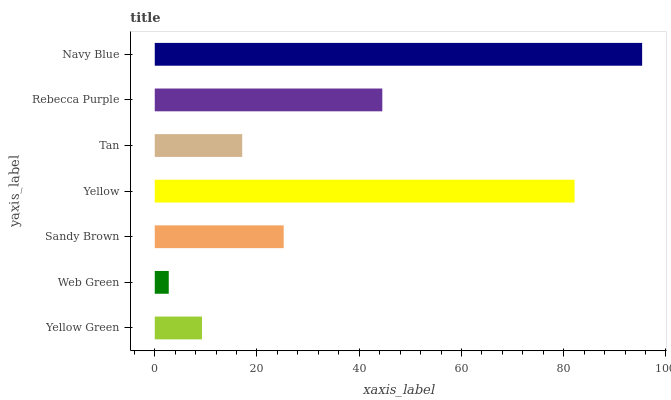Is Web Green the minimum?
Answer yes or no. Yes. Is Navy Blue the maximum?
Answer yes or no. Yes. Is Sandy Brown the minimum?
Answer yes or no. No. Is Sandy Brown the maximum?
Answer yes or no. No. Is Sandy Brown greater than Web Green?
Answer yes or no. Yes. Is Web Green less than Sandy Brown?
Answer yes or no. Yes. Is Web Green greater than Sandy Brown?
Answer yes or no. No. Is Sandy Brown less than Web Green?
Answer yes or no. No. Is Sandy Brown the high median?
Answer yes or no. Yes. Is Sandy Brown the low median?
Answer yes or no. Yes. Is Navy Blue the high median?
Answer yes or no. No. Is Web Green the low median?
Answer yes or no. No. 